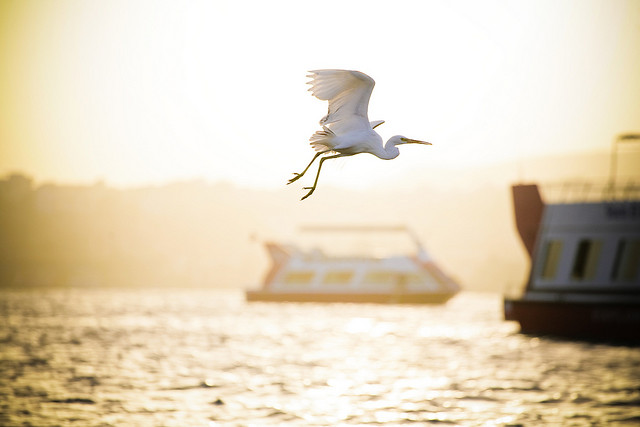Can you describe the bird in the image? The image features a white bird in mid-flight, likely an egret, gracefully soaring with wings spread wide against the backdrop of a serene waterway. 